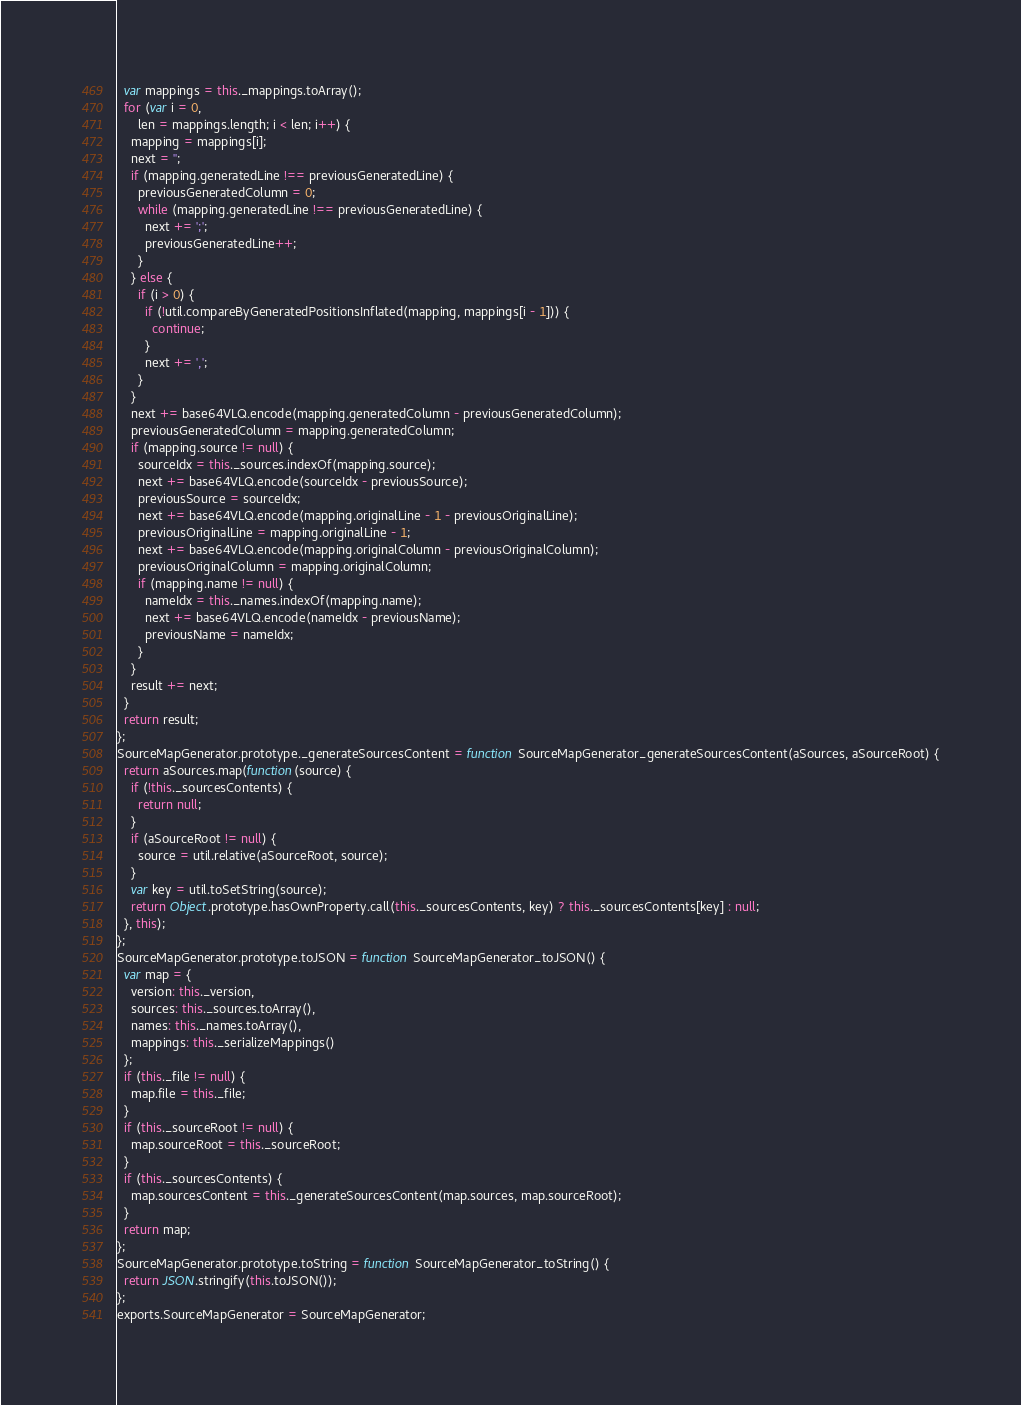<code> <loc_0><loc_0><loc_500><loc_500><_JavaScript_>  var mappings = this._mappings.toArray();
  for (var i = 0,
      len = mappings.length; i < len; i++) {
    mapping = mappings[i];
    next = '';
    if (mapping.generatedLine !== previousGeneratedLine) {
      previousGeneratedColumn = 0;
      while (mapping.generatedLine !== previousGeneratedLine) {
        next += ';';
        previousGeneratedLine++;
      }
    } else {
      if (i > 0) {
        if (!util.compareByGeneratedPositionsInflated(mapping, mappings[i - 1])) {
          continue;
        }
        next += ',';
      }
    }
    next += base64VLQ.encode(mapping.generatedColumn - previousGeneratedColumn);
    previousGeneratedColumn = mapping.generatedColumn;
    if (mapping.source != null) {
      sourceIdx = this._sources.indexOf(mapping.source);
      next += base64VLQ.encode(sourceIdx - previousSource);
      previousSource = sourceIdx;
      next += base64VLQ.encode(mapping.originalLine - 1 - previousOriginalLine);
      previousOriginalLine = mapping.originalLine - 1;
      next += base64VLQ.encode(mapping.originalColumn - previousOriginalColumn);
      previousOriginalColumn = mapping.originalColumn;
      if (mapping.name != null) {
        nameIdx = this._names.indexOf(mapping.name);
        next += base64VLQ.encode(nameIdx - previousName);
        previousName = nameIdx;
      }
    }
    result += next;
  }
  return result;
};
SourceMapGenerator.prototype._generateSourcesContent = function SourceMapGenerator_generateSourcesContent(aSources, aSourceRoot) {
  return aSources.map(function(source) {
    if (!this._sourcesContents) {
      return null;
    }
    if (aSourceRoot != null) {
      source = util.relative(aSourceRoot, source);
    }
    var key = util.toSetString(source);
    return Object.prototype.hasOwnProperty.call(this._sourcesContents, key) ? this._sourcesContents[key] : null;
  }, this);
};
SourceMapGenerator.prototype.toJSON = function SourceMapGenerator_toJSON() {
  var map = {
    version: this._version,
    sources: this._sources.toArray(),
    names: this._names.toArray(),
    mappings: this._serializeMappings()
  };
  if (this._file != null) {
    map.file = this._file;
  }
  if (this._sourceRoot != null) {
    map.sourceRoot = this._sourceRoot;
  }
  if (this._sourcesContents) {
    map.sourcesContent = this._generateSourcesContent(map.sources, map.sourceRoot);
  }
  return map;
};
SourceMapGenerator.prototype.toString = function SourceMapGenerator_toString() {
  return JSON.stringify(this.toJSON());
};
exports.SourceMapGenerator = SourceMapGenerator;
</code> 